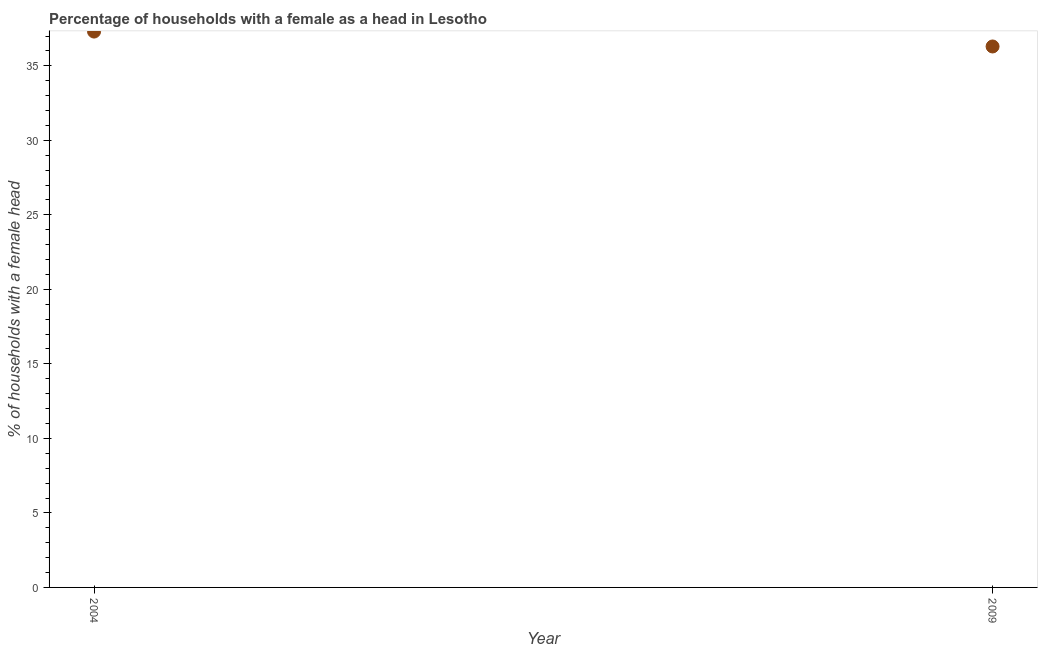What is the number of female supervised households in 2009?
Offer a terse response. 36.3. Across all years, what is the maximum number of female supervised households?
Your response must be concise. 37.3. Across all years, what is the minimum number of female supervised households?
Give a very brief answer. 36.3. In which year was the number of female supervised households maximum?
Your answer should be very brief. 2004. What is the sum of the number of female supervised households?
Provide a short and direct response. 73.6. What is the difference between the number of female supervised households in 2004 and 2009?
Your answer should be compact. 1. What is the average number of female supervised households per year?
Your answer should be very brief. 36.8. What is the median number of female supervised households?
Make the answer very short. 36.8. Do a majority of the years between 2009 and 2004 (inclusive) have number of female supervised households greater than 30 %?
Offer a very short reply. No. What is the ratio of the number of female supervised households in 2004 to that in 2009?
Provide a succinct answer. 1.03. Is the number of female supervised households in 2004 less than that in 2009?
Ensure brevity in your answer.  No. How many dotlines are there?
Your answer should be very brief. 1. How many years are there in the graph?
Make the answer very short. 2. Does the graph contain any zero values?
Give a very brief answer. No. What is the title of the graph?
Offer a terse response. Percentage of households with a female as a head in Lesotho. What is the label or title of the X-axis?
Offer a terse response. Year. What is the label or title of the Y-axis?
Your answer should be very brief. % of households with a female head. What is the % of households with a female head in 2004?
Give a very brief answer. 37.3. What is the % of households with a female head in 2009?
Offer a terse response. 36.3. What is the difference between the % of households with a female head in 2004 and 2009?
Your answer should be very brief. 1. What is the ratio of the % of households with a female head in 2004 to that in 2009?
Ensure brevity in your answer.  1.03. 